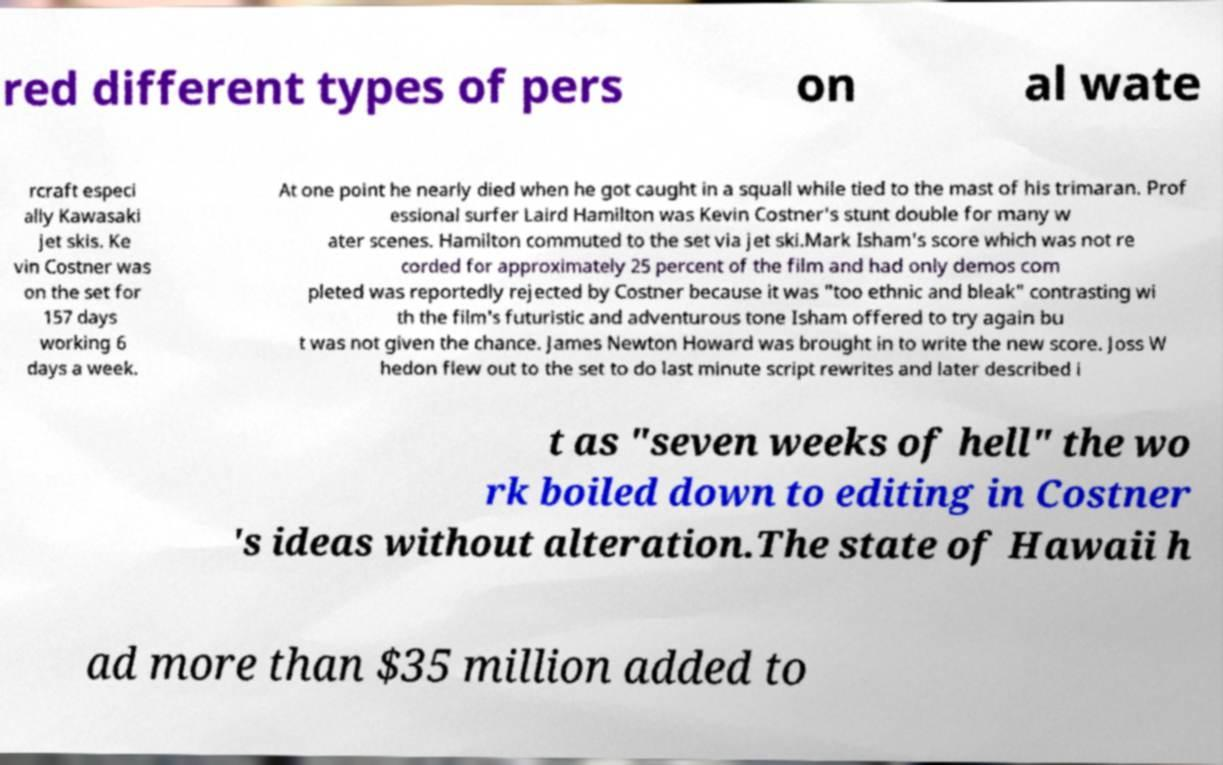What messages or text are displayed in this image? I need them in a readable, typed format. red different types of pers on al wate rcraft especi ally Kawasaki jet skis. Ke vin Costner was on the set for 157 days working 6 days a week. At one point he nearly died when he got caught in a squall while tied to the mast of his trimaran. Prof essional surfer Laird Hamilton was Kevin Costner's stunt double for many w ater scenes. Hamilton commuted to the set via jet ski.Mark Isham's score which was not re corded for approximately 25 percent of the film and had only demos com pleted was reportedly rejected by Costner because it was "too ethnic and bleak" contrasting wi th the film's futuristic and adventurous tone Isham offered to try again bu t was not given the chance. James Newton Howard was brought in to write the new score. Joss W hedon flew out to the set to do last minute script rewrites and later described i t as "seven weeks of hell" the wo rk boiled down to editing in Costner 's ideas without alteration.The state of Hawaii h ad more than $35 million added to 